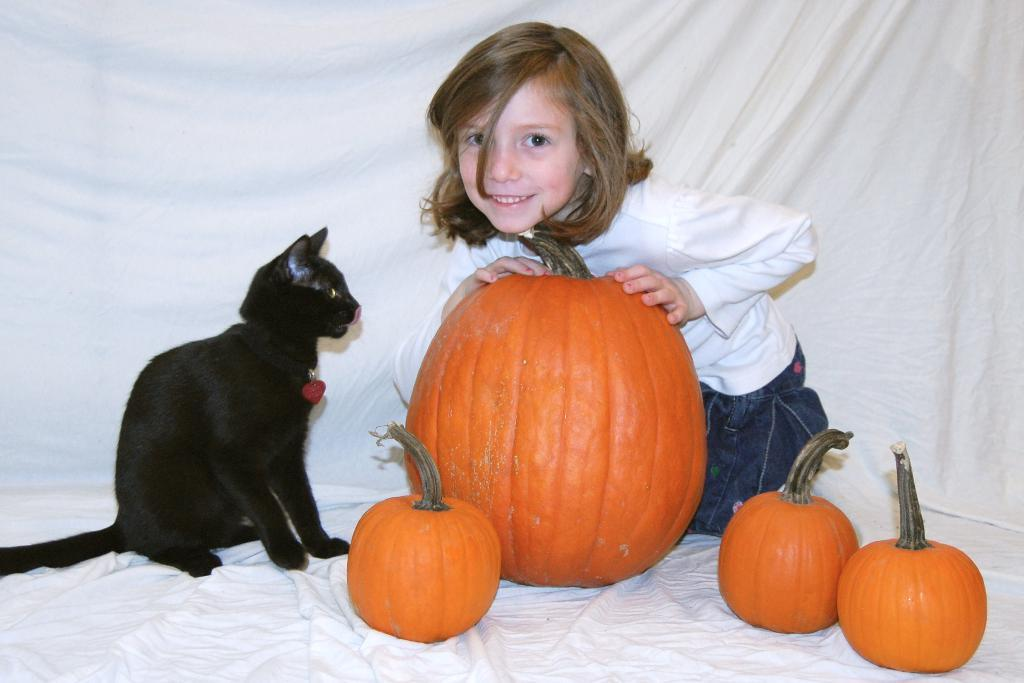What objects are on the cloth in the image? There are pumpkins on the cloth in the image. What type of animal is present in the image? There is a cat in the image. Who else is present in the image besides the cat? There is a kid in the image. Where are the cat and kid located in the image? The cat and kid are in the middle of the image. What can be seen in the background of the image? There is a white cloth visible in the background of the image. What type of steam is coming out of the pumpkins in the image? There is no steam coming out of the pumpkins in the image; they are stationary objects on the cloth. 